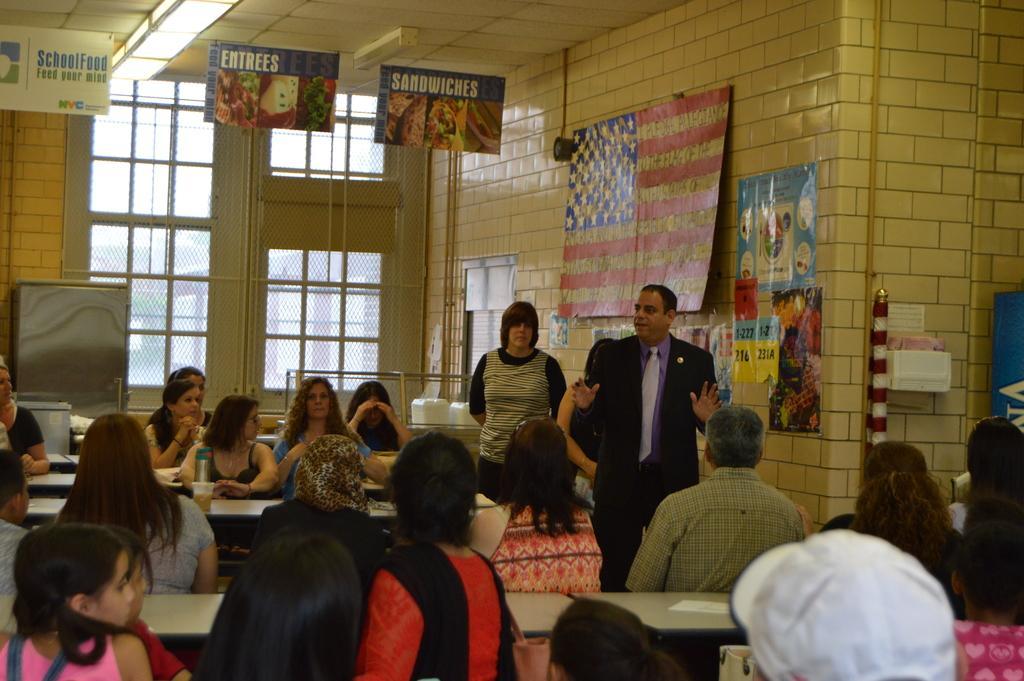Describe this image in one or two sentences. In this image we can see a group of people sitting on chairs, some tables, a bottle and cup placed on the table. In the center of the image we can see some persons standing. To the right side of the image we can see a box with some papers placed on the wall, pole, group of poster, flag and banners with some text. In the background, we can see windows, some lights, plates and a door. 